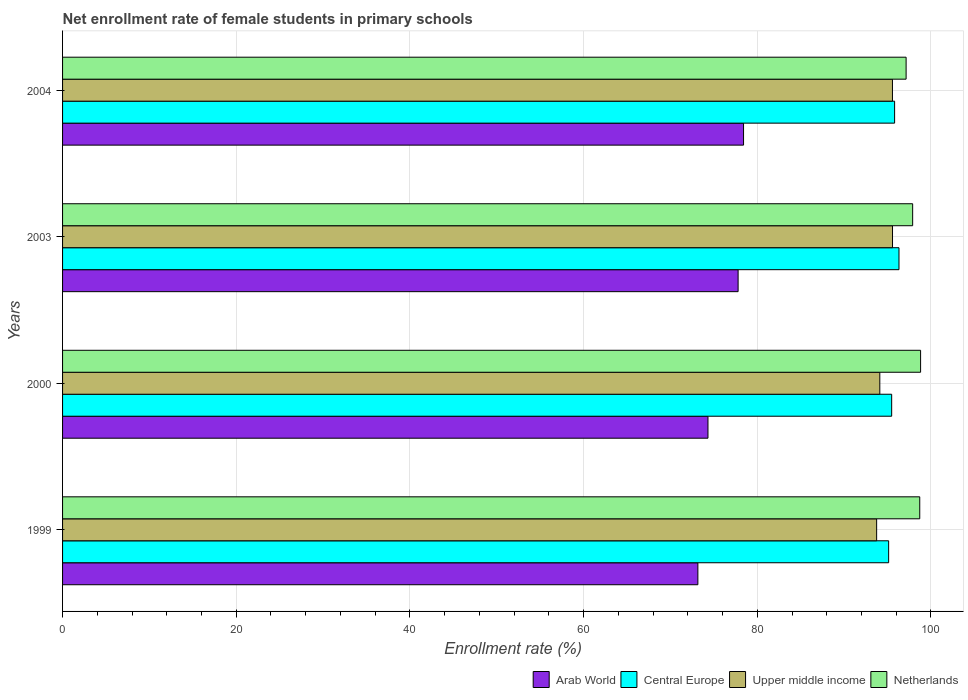How many groups of bars are there?
Your response must be concise. 4. Are the number of bars per tick equal to the number of legend labels?
Give a very brief answer. Yes. Are the number of bars on each tick of the Y-axis equal?
Offer a very short reply. Yes. In how many cases, is the number of bars for a given year not equal to the number of legend labels?
Your response must be concise. 0. What is the net enrollment rate of female students in primary schools in Netherlands in 2000?
Provide a succinct answer. 98.81. Across all years, what is the maximum net enrollment rate of female students in primary schools in Arab World?
Your response must be concise. 78.42. Across all years, what is the minimum net enrollment rate of female students in primary schools in Upper middle income?
Provide a short and direct response. 93.74. In which year was the net enrollment rate of female students in primary schools in Arab World maximum?
Provide a succinct answer. 2004. In which year was the net enrollment rate of female students in primary schools in Netherlands minimum?
Ensure brevity in your answer.  2004. What is the total net enrollment rate of female students in primary schools in Arab World in the graph?
Your answer should be very brief. 303.69. What is the difference between the net enrollment rate of female students in primary schools in Netherlands in 1999 and that in 2000?
Ensure brevity in your answer.  -0.1. What is the difference between the net enrollment rate of female students in primary schools in Upper middle income in 2004 and the net enrollment rate of female students in primary schools in Arab World in 1999?
Ensure brevity in your answer.  22.41. What is the average net enrollment rate of female students in primary schools in Netherlands per year?
Your response must be concise. 98.14. In the year 2004, what is the difference between the net enrollment rate of female students in primary schools in Central Europe and net enrollment rate of female students in primary schools in Netherlands?
Give a very brief answer. -1.32. What is the ratio of the net enrollment rate of female students in primary schools in Arab World in 2000 to that in 2004?
Offer a terse response. 0.95. Is the net enrollment rate of female students in primary schools in Upper middle income in 2000 less than that in 2003?
Keep it short and to the point. Yes. What is the difference between the highest and the second highest net enrollment rate of female students in primary schools in Central Europe?
Ensure brevity in your answer.  0.5. What is the difference between the highest and the lowest net enrollment rate of female students in primary schools in Upper middle income?
Ensure brevity in your answer.  1.83. In how many years, is the net enrollment rate of female students in primary schools in Upper middle income greater than the average net enrollment rate of female students in primary schools in Upper middle income taken over all years?
Your response must be concise. 2. What does the 3rd bar from the top in 2004 represents?
Make the answer very short. Central Europe. What does the 1st bar from the bottom in 2003 represents?
Make the answer very short. Arab World. How many bars are there?
Provide a short and direct response. 16. Does the graph contain any zero values?
Offer a terse response. No. Does the graph contain grids?
Your answer should be compact. Yes. How many legend labels are there?
Give a very brief answer. 4. What is the title of the graph?
Your response must be concise. Net enrollment rate of female students in primary schools. Does "Argentina" appear as one of the legend labels in the graph?
Ensure brevity in your answer.  No. What is the label or title of the X-axis?
Provide a short and direct response. Enrollment rate (%). What is the label or title of the Y-axis?
Offer a very short reply. Years. What is the Enrollment rate (%) in Arab World in 1999?
Make the answer very short. 73.16. What is the Enrollment rate (%) of Central Europe in 1999?
Provide a succinct answer. 95.13. What is the Enrollment rate (%) of Upper middle income in 1999?
Provide a succinct answer. 93.74. What is the Enrollment rate (%) of Netherlands in 1999?
Offer a very short reply. 98.71. What is the Enrollment rate (%) in Arab World in 2000?
Offer a terse response. 74.32. What is the Enrollment rate (%) in Central Europe in 2000?
Your response must be concise. 95.47. What is the Enrollment rate (%) in Upper middle income in 2000?
Give a very brief answer. 94.11. What is the Enrollment rate (%) of Netherlands in 2000?
Offer a terse response. 98.81. What is the Enrollment rate (%) of Arab World in 2003?
Make the answer very short. 77.79. What is the Enrollment rate (%) in Central Europe in 2003?
Ensure brevity in your answer.  96.32. What is the Enrollment rate (%) in Upper middle income in 2003?
Offer a very short reply. 95.57. What is the Enrollment rate (%) in Netherlands in 2003?
Provide a short and direct response. 97.89. What is the Enrollment rate (%) of Arab World in 2004?
Your answer should be compact. 78.42. What is the Enrollment rate (%) of Central Europe in 2004?
Your answer should be compact. 95.81. What is the Enrollment rate (%) in Upper middle income in 2004?
Your answer should be very brief. 95.57. What is the Enrollment rate (%) in Netherlands in 2004?
Ensure brevity in your answer.  97.14. Across all years, what is the maximum Enrollment rate (%) of Arab World?
Provide a short and direct response. 78.42. Across all years, what is the maximum Enrollment rate (%) of Central Europe?
Make the answer very short. 96.32. Across all years, what is the maximum Enrollment rate (%) of Upper middle income?
Give a very brief answer. 95.57. Across all years, what is the maximum Enrollment rate (%) in Netherlands?
Ensure brevity in your answer.  98.81. Across all years, what is the minimum Enrollment rate (%) of Arab World?
Ensure brevity in your answer.  73.16. Across all years, what is the minimum Enrollment rate (%) in Central Europe?
Offer a very short reply. 95.13. Across all years, what is the minimum Enrollment rate (%) in Upper middle income?
Ensure brevity in your answer.  93.74. Across all years, what is the minimum Enrollment rate (%) of Netherlands?
Your answer should be compact. 97.14. What is the total Enrollment rate (%) in Arab World in the graph?
Your answer should be very brief. 303.69. What is the total Enrollment rate (%) of Central Europe in the graph?
Give a very brief answer. 382.73. What is the total Enrollment rate (%) in Upper middle income in the graph?
Keep it short and to the point. 378.99. What is the total Enrollment rate (%) of Netherlands in the graph?
Your answer should be compact. 392.55. What is the difference between the Enrollment rate (%) of Arab World in 1999 and that in 2000?
Provide a succinct answer. -1.16. What is the difference between the Enrollment rate (%) in Central Europe in 1999 and that in 2000?
Offer a terse response. -0.35. What is the difference between the Enrollment rate (%) of Upper middle income in 1999 and that in 2000?
Offer a terse response. -0.37. What is the difference between the Enrollment rate (%) in Netherlands in 1999 and that in 2000?
Offer a terse response. -0.1. What is the difference between the Enrollment rate (%) in Arab World in 1999 and that in 2003?
Your response must be concise. -4.63. What is the difference between the Enrollment rate (%) in Central Europe in 1999 and that in 2003?
Provide a short and direct response. -1.19. What is the difference between the Enrollment rate (%) in Upper middle income in 1999 and that in 2003?
Give a very brief answer. -1.83. What is the difference between the Enrollment rate (%) of Netherlands in 1999 and that in 2003?
Your response must be concise. 0.82. What is the difference between the Enrollment rate (%) of Arab World in 1999 and that in 2004?
Keep it short and to the point. -5.26. What is the difference between the Enrollment rate (%) in Central Europe in 1999 and that in 2004?
Your answer should be very brief. -0.69. What is the difference between the Enrollment rate (%) of Upper middle income in 1999 and that in 2004?
Your response must be concise. -1.82. What is the difference between the Enrollment rate (%) of Netherlands in 1999 and that in 2004?
Ensure brevity in your answer.  1.57. What is the difference between the Enrollment rate (%) of Arab World in 2000 and that in 2003?
Offer a very short reply. -3.47. What is the difference between the Enrollment rate (%) in Central Europe in 2000 and that in 2003?
Offer a very short reply. -0.84. What is the difference between the Enrollment rate (%) of Upper middle income in 2000 and that in 2003?
Your answer should be compact. -1.46. What is the difference between the Enrollment rate (%) of Netherlands in 2000 and that in 2003?
Offer a terse response. 0.91. What is the difference between the Enrollment rate (%) of Arab World in 2000 and that in 2004?
Keep it short and to the point. -4.1. What is the difference between the Enrollment rate (%) in Central Europe in 2000 and that in 2004?
Offer a terse response. -0.34. What is the difference between the Enrollment rate (%) of Upper middle income in 2000 and that in 2004?
Your answer should be compact. -1.46. What is the difference between the Enrollment rate (%) of Netherlands in 2000 and that in 2004?
Keep it short and to the point. 1.67. What is the difference between the Enrollment rate (%) of Arab World in 2003 and that in 2004?
Provide a succinct answer. -0.63. What is the difference between the Enrollment rate (%) in Central Europe in 2003 and that in 2004?
Your answer should be compact. 0.5. What is the difference between the Enrollment rate (%) of Upper middle income in 2003 and that in 2004?
Provide a short and direct response. 0.01. What is the difference between the Enrollment rate (%) of Netherlands in 2003 and that in 2004?
Make the answer very short. 0.75. What is the difference between the Enrollment rate (%) of Arab World in 1999 and the Enrollment rate (%) of Central Europe in 2000?
Offer a very short reply. -22.32. What is the difference between the Enrollment rate (%) of Arab World in 1999 and the Enrollment rate (%) of Upper middle income in 2000?
Provide a short and direct response. -20.95. What is the difference between the Enrollment rate (%) of Arab World in 1999 and the Enrollment rate (%) of Netherlands in 2000?
Make the answer very short. -25.65. What is the difference between the Enrollment rate (%) of Central Europe in 1999 and the Enrollment rate (%) of Upper middle income in 2000?
Provide a succinct answer. 1.02. What is the difference between the Enrollment rate (%) in Central Europe in 1999 and the Enrollment rate (%) in Netherlands in 2000?
Ensure brevity in your answer.  -3.68. What is the difference between the Enrollment rate (%) of Upper middle income in 1999 and the Enrollment rate (%) of Netherlands in 2000?
Offer a very short reply. -5.06. What is the difference between the Enrollment rate (%) of Arab World in 1999 and the Enrollment rate (%) of Central Europe in 2003?
Offer a very short reply. -23.16. What is the difference between the Enrollment rate (%) of Arab World in 1999 and the Enrollment rate (%) of Upper middle income in 2003?
Your answer should be compact. -22.41. What is the difference between the Enrollment rate (%) in Arab World in 1999 and the Enrollment rate (%) in Netherlands in 2003?
Your answer should be compact. -24.73. What is the difference between the Enrollment rate (%) in Central Europe in 1999 and the Enrollment rate (%) in Upper middle income in 2003?
Your answer should be very brief. -0.45. What is the difference between the Enrollment rate (%) in Central Europe in 1999 and the Enrollment rate (%) in Netherlands in 2003?
Provide a short and direct response. -2.77. What is the difference between the Enrollment rate (%) of Upper middle income in 1999 and the Enrollment rate (%) of Netherlands in 2003?
Keep it short and to the point. -4.15. What is the difference between the Enrollment rate (%) of Arab World in 1999 and the Enrollment rate (%) of Central Europe in 2004?
Your answer should be very brief. -22.66. What is the difference between the Enrollment rate (%) in Arab World in 1999 and the Enrollment rate (%) in Upper middle income in 2004?
Keep it short and to the point. -22.41. What is the difference between the Enrollment rate (%) in Arab World in 1999 and the Enrollment rate (%) in Netherlands in 2004?
Make the answer very short. -23.98. What is the difference between the Enrollment rate (%) in Central Europe in 1999 and the Enrollment rate (%) in Upper middle income in 2004?
Offer a very short reply. -0.44. What is the difference between the Enrollment rate (%) of Central Europe in 1999 and the Enrollment rate (%) of Netherlands in 2004?
Provide a succinct answer. -2.01. What is the difference between the Enrollment rate (%) in Upper middle income in 1999 and the Enrollment rate (%) in Netherlands in 2004?
Offer a terse response. -3.39. What is the difference between the Enrollment rate (%) in Arab World in 2000 and the Enrollment rate (%) in Central Europe in 2003?
Your answer should be very brief. -22. What is the difference between the Enrollment rate (%) in Arab World in 2000 and the Enrollment rate (%) in Upper middle income in 2003?
Provide a short and direct response. -21.25. What is the difference between the Enrollment rate (%) of Arab World in 2000 and the Enrollment rate (%) of Netherlands in 2003?
Provide a short and direct response. -23.57. What is the difference between the Enrollment rate (%) of Central Europe in 2000 and the Enrollment rate (%) of Upper middle income in 2003?
Your response must be concise. -0.1. What is the difference between the Enrollment rate (%) in Central Europe in 2000 and the Enrollment rate (%) in Netherlands in 2003?
Your response must be concise. -2.42. What is the difference between the Enrollment rate (%) of Upper middle income in 2000 and the Enrollment rate (%) of Netherlands in 2003?
Ensure brevity in your answer.  -3.78. What is the difference between the Enrollment rate (%) of Arab World in 2000 and the Enrollment rate (%) of Central Europe in 2004?
Your answer should be very brief. -21.49. What is the difference between the Enrollment rate (%) in Arab World in 2000 and the Enrollment rate (%) in Upper middle income in 2004?
Provide a short and direct response. -21.25. What is the difference between the Enrollment rate (%) of Arab World in 2000 and the Enrollment rate (%) of Netherlands in 2004?
Your response must be concise. -22.82. What is the difference between the Enrollment rate (%) in Central Europe in 2000 and the Enrollment rate (%) in Upper middle income in 2004?
Give a very brief answer. -0.09. What is the difference between the Enrollment rate (%) of Central Europe in 2000 and the Enrollment rate (%) of Netherlands in 2004?
Ensure brevity in your answer.  -1.66. What is the difference between the Enrollment rate (%) in Upper middle income in 2000 and the Enrollment rate (%) in Netherlands in 2004?
Your response must be concise. -3.03. What is the difference between the Enrollment rate (%) in Arab World in 2003 and the Enrollment rate (%) in Central Europe in 2004?
Provide a short and direct response. -18.02. What is the difference between the Enrollment rate (%) of Arab World in 2003 and the Enrollment rate (%) of Upper middle income in 2004?
Provide a succinct answer. -17.77. What is the difference between the Enrollment rate (%) of Arab World in 2003 and the Enrollment rate (%) of Netherlands in 2004?
Make the answer very short. -19.35. What is the difference between the Enrollment rate (%) of Central Europe in 2003 and the Enrollment rate (%) of Upper middle income in 2004?
Make the answer very short. 0.75. What is the difference between the Enrollment rate (%) of Central Europe in 2003 and the Enrollment rate (%) of Netherlands in 2004?
Your response must be concise. -0.82. What is the difference between the Enrollment rate (%) of Upper middle income in 2003 and the Enrollment rate (%) of Netherlands in 2004?
Make the answer very short. -1.57. What is the average Enrollment rate (%) of Arab World per year?
Ensure brevity in your answer.  75.92. What is the average Enrollment rate (%) in Central Europe per year?
Provide a short and direct response. 95.68. What is the average Enrollment rate (%) of Upper middle income per year?
Ensure brevity in your answer.  94.75. What is the average Enrollment rate (%) in Netherlands per year?
Give a very brief answer. 98.14. In the year 1999, what is the difference between the Enrollment rate (%) of Arab World and Enrollment rate (%) of Central Europe?
Ensure brevity in your answer.  -21.97. In the year 1999, what is the difference between the Enrollment rate (%) in Arab World and Enrollment rate (%) in Upper middle income?
Your answer should be compact. -20.59. In the year 1999, what is the difference between the Enrollment rate (%) in Arab World and Enrollment rate (%) in Netherlands?
Your answer should be very brief. -25.55. In the year 1999, what is the difference between the Enrollment rate (%) in Central Europe and Enrollment rate (%) in Upper middle income?
Ensure brevity in your answer.  1.38. In the year 1999, what is the difference between the Enrollment rate (%) of Central Europe and Enrollment rate (%) of Netherlands?
Ensure brevity in your answer.  -3.58. In the year 1999, what is the difference between the Enrollment rate (%) of Upper middle income and Enrollment rate (%) of Netherlands?
Ensure brevity in your answer.  -4.96. In the year 2000, what is the difference between the Enrollment rate (%) in Arab World and Enrollment rate (%) in Central Europe?
Ensure brevity in your answer.  -21.15. In the year 2000, what is the difference between the Enrollment rate (%) of Arab World and Enrollment rate (%) of Upper middle income?
Offer a very short reply. -19.79. In the year 2000, what is the difference between the Enrollment rate (%) of Arab World and Enrollment rate (%) of Netherlands?
Make the answer very short. -24.49. In the year 2000, what is the difference between the Enrollment rate (%) of Central Europe and Enrollment rate (%) of Upper middle income?
Provide a short and direct response. 1.36. In the year 2000, what is the difference between the Enrollment rate (%) in Central Europe and Enrollment rate (%) in Netherlands?
Offer a very short reply. -3.33. In the year 2000, what is the difference between the Enrollment rate (%) of Upper middle income and Enrollment rate (%) of Netherlands?
Give a very brief answer. -4.7. In the year 2003, what is the difference between the Enrollment rate (%) of Arab World and Enrollment rate (%) of Central Europe?
Your response must be concise. -18.53. In the year 2003, what is the difference between the Enrollment rate (%) in Arab World and Enrollment rate (%) in Upper middle income?
Provide a short and direct response. -17.78. In the year 2003, what is the difference between the Enrollment rate (%) of Arab World and Enrollment rate (%) of Netherlands?
Provide a short and direct response. -20.1. In the year 2003, what is the difference between the Enrollment rate (%) in Central Europe and Enrollment rate (%) in Upper middle income?
Offer a very short reply. 0.74. In the year 2003, what is the difference between the Enrollment rate (%) in Central Europe and Enrollment rate (%) in Netherlands?
Offer a terse response. -1.58. In the year 2003, what is the difference between the Enrollment rate (%) in Upper middle income and Enrollment rate (%) in Netherlands?
Offer a terse response. -2.32. In the year 2004, what is the difference between the Enrollment rate (%) in Arab World and Enrollment rate (%) in Central Europe?
Make the answer very short. -17.4. In the year 2004, what is the difference between the Enrollment rate (%) in Arab World and Enrollment rate (%) in Upper middle income?
Your response must be concise. -17.15. In the year 2004, what is the difference between the Enrollment rate (%) in Arab World and Enrollment rate (%) in Netherlands?
Provide a short and direct response. -18.72. In the year 2004, what is the difference between the Enrollment rate (%) of Central Europe and Enrollment rate (%) of Upper middle income?
Offer a very short reply. 0.25. In the year 2004, what is the difference between the Enrollment rate (%) of Central Europe and Enrollment rate (%) of Netherlands?
Offer a very short reply. -1.32. In the year 2004, what is the difference between the Enrollment rate (%) of Upper middle income and Enrollment rate (%) of Netherlands?
Ensure brevity in your answer.  -1.57. What is the ratio of the Enrollment rate (%) of Arab World in 1999 to that in 2000?
Offer a very short reply. 0.98. What is the ratio of the Enrollment rate (%) in Arab World in 1999 to that in 2003?
Provide a short and direct response. 0.94. What is the ratio of the Enrollment rate (%) in Central Europe in 1999 to that in 2003?
Your response must be concise. 0.99. What is the ratio of the Enrollment rate (%) in Upper middle income in 1999 to that in 2003?
Keep it short and to the point. 0.98. What is the ratio of the Enrollment rate (%) of Netherlands in 1999 to that in 2003?
Keep it short and to the point. 1.01. What is the ratio of the Enrollment rate (%) in Arab World in 1999 to that in 2004?
Your answer should be very brief. 0.93. What is the ratio of the Enrollment rate (%) of Upper middle income in 1999 to that in 2004?
Make the answer very short. 0.98. What is the ratio of the Enrollment rate (%) of Netherlands in 1999 to that in 2004?
Your answer should be compact. 1.02. What is the ratio of the Enrollment rate (%) of Arab World in 2000 to that in 2003?
Offer a very short reply. 0.96. What is the ratio of the Enrollment rate (%) of Central Europe in 2000 to that in 2003?
Offer a very short reply. 0.99. What is the ratio of the Enrollment rate (%) of Upper middle income in 2000 to that in 2003?
Make the answer very short. 0.98. What is the ratio of the Enrollment rate (%) of Netherlands in 2000 to that in 2003?
Offer a terse response. 1.01. What is the ratio of the Enrollment rate (%) in Arab World in 2000 to that in 2004?
Make the answer very short. 0.95. What is the ratio of the Enrollment rate (%) in Upper middle income in 2000 to that in 2004?
Keep it short and to the point. 0.98. What is the ratio of the Enrollment rate (%) of Netherlands in 2000 to that in 2004?
Your answer should be compact. 1.02. What is the ratio of the Enrollment rate (%) of Upper middle income in 2003 to that in 2004?
Provide a succinct answer. 1. What is the difference between the highest and the second highest Enrollment rate (%) in Arab World?
Make the answer very short. 0.63. What is the difference between the highest and the second highest Enrollment rate (%) in Central Europe?
Your response must be concise. 0.5. What is the difference between the highest and the second highest Enrollment rate (%) in Upper middle income?
Keep it short and to the point. 0.01. What is the difference between the highest and the second highest Enrollment rate (%) in Netherlands?
Provide a short and direct response. 0.1. What is the difference between the highest and the lowest Enrollment rate (%) of Arab World?
Your response must be concise. 5.26. What is the difference between the highest and the lowest Enrollment rate (%) in Central Europe?
Offer a terse response. 1.19. What is the difference between the highest and the lowest Enrollment rate (%) of Upper middle income?
Keep it short and to the point. 1.83. What is the difference between the highest and the lowest Enrollment rate (%) of Netherlands?
Keep it short and to the point. 1.67. 